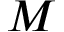Convert formula to latex. <formula><loc_0><loc_0><loc_500><loc_500>M</formula> 